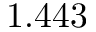<formula> <loc_0><loc_0><loc_500><loc_500>1 . 4 4 3</formula> 